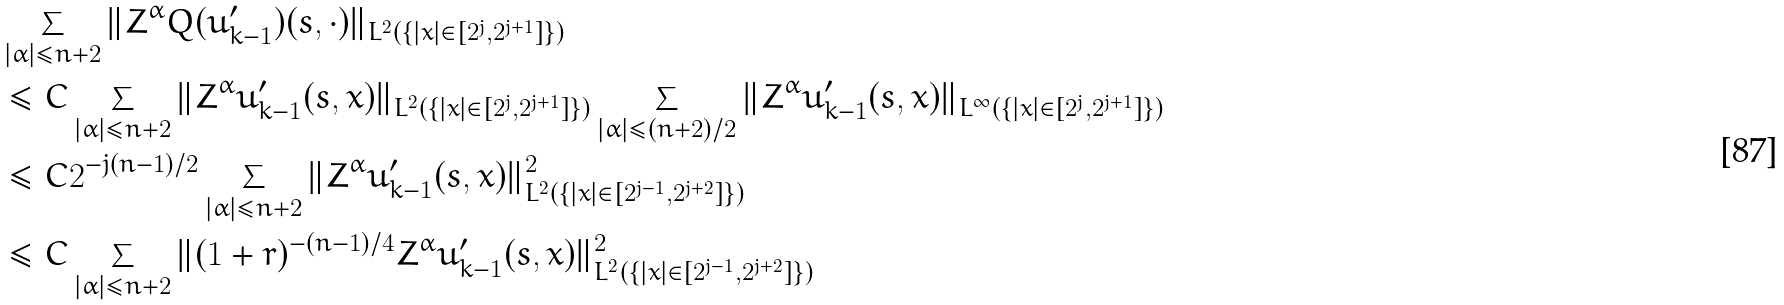Convert formula to latex. <formula><loc_0><loc_0><loc_500><loc_500>& \sum _ { | \alpha | \leq n + 2 } \| Z ^ { \alpha } Q ( u ^ { \prime } _ { k - 1 } ) ( s , \cdot ) \| _ { L ^ { 2 } ( \{ | x | \in [ 2 ^ { j } , 2 ^ { j + 1 } ] \} ) } \\ & \leq C \sum _ { | \alpha | \leq n + 2 } \| Z ^ { \alpha } u ^ { \prime } _ { k - 1 } ( s , x ) \| _ { L ^ { 2 } ( \{ | x | \in [ 2 ^ { j } , 2 ^ { j + 1 } ] \} ) } \sum _ { | \alpha | \leq ( n + 2 ) / 2 } \| Z ^ { \alpha } u ^ { \prime } _ { k - 1 } ( s , x ) \| _ { L ^ { \infty } ( \{ | x | \in [ 2 ^ { j } , 2 ^ { j + 1 } ] \} ) } \\ & \leq C 2 ^ { - j ( n - 1 ) / 2 } \sum _ { | \alpha | \leq n + 2 } \| Z ^ { \alpha } u ^ { \prime } _ { k - 1 } ( s , x ) \| ^ { 2 } _ { L ^ { 2 } ( \{ | x | \in [ 2 ^ { j - 1 } , 2 ^ { j + 2 } ] \} ) } \\ & \leq C \sum _ { | \alpha | \leq n + 2 } \| ( 1 + r ) ^ { - ( n - 1 ) / 4 } Z ^ { \alpha } u ^ { \prime } _ { k - 1 } ( s , x ) \| ^ { 2 } _ { L ^ { 2 } ( \{ | x | \in [ 2 ^ { j - 1 } , 2 ^ { j + 2 } ] \} ) }</formula> 